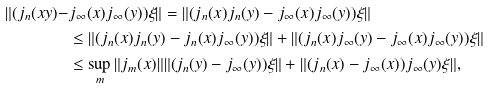Convert formula to latex. <formula><loc_0><loc_0><loc_500><loc_500>\| ( j _ { n } ( x y ) - & j _ { \infty } ( x ) j _ { \infty } ( y ) ) \xi \| = \| ( j _ { n } ( x ) j _ { n } ( y ) - j _ { \infty } ( x ) j _ { \infty } ( y ) ) \xi \| \\ & \leq \| ( j _ { n } ( x ) j _ { n } ( y ) - j _ { n } ( x ) j _ { \infty } ( y ) ) \xi \| + \| ( j _ { n } ( x ) j _ { \infty } ( y ) - j _ { \infty } ( x ) j _ { \infty } ( y ) ) \xi \| \\ & \leq \sup _ { m } \| j _ { m } ( x ) \| \| ( j _ { n } ( y ) - j _ { \infty } ( y ) ) \xi \| + \| ( j _ { n } ( x ) - j _ { \infty } ( x ) ) j _ { \infty } ( y ) \xi \| ,</formula> 